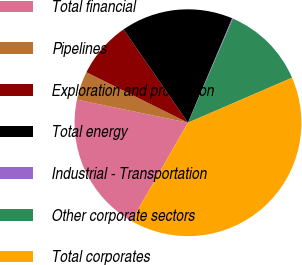Convert chart to OTSL. <chart><loc_0><loc_0><loc_500><loc_500><pie_chart><fcel>Total financial<fcel>Pipelines<fcel>Exploration and production<fcel>Total energy<fcel>Industrial - Transportation<fcel>Other corporate sectors<fcel>Total corporates<nl><fcel>19.96%<fcel>4.08%<fcel>8.05%<fcel>15.99%<fcel>0.11%<fcel>12.02%<fcel>39.81%<nl></chart> 